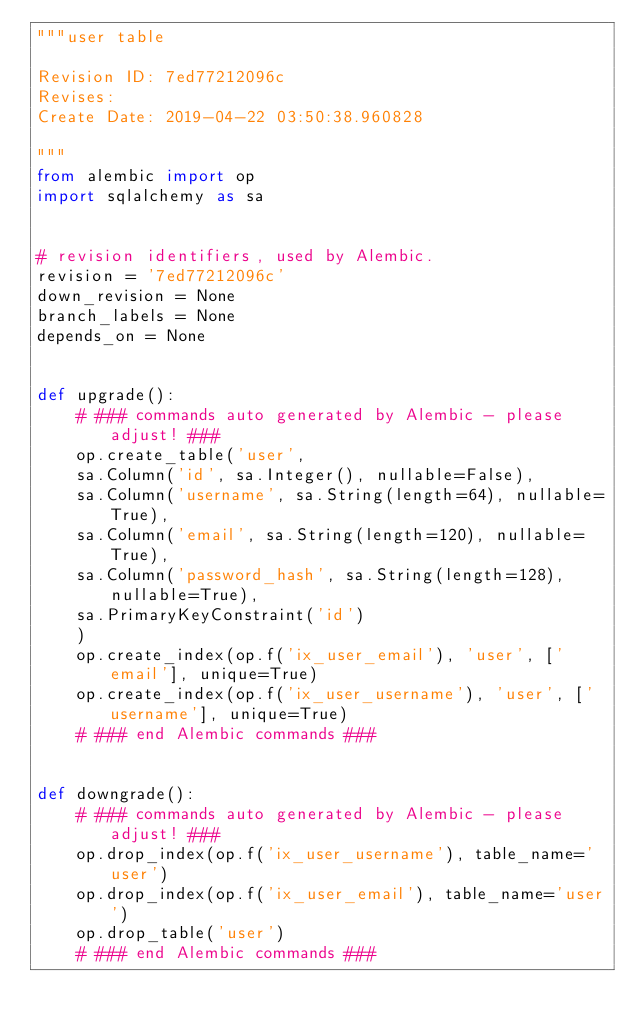<code> <loc_0><loc_0><loc_500><loc_500><_Python_>"""user table

Revision ID: 7ed77212096c
Revises: 
Create Date: 2019-04-22 03:50:38.960828

"""
from alembic import op
import sqlalchemy as sa


# revision identifiers, used by Alembic.
revision = '7ed77212096c'
down_revision = None
branch_labels = None
depends_on = None


def upgrade():
    # ### commands auto generated by Alembic - please adjust! ###
    op.create_table('user',
    sa.Column('id', sa.Integer(), nullable=False),
    sa.Column('username', sa.String(length=64), nullable=True),
    sa.Column('email', sa.String(length=120), nullable=True),
    sa.Column('password_hash', sa.String(length=128), nullable=True),
    sa.PrimaryKeyConstraint('id')
    )
    op.create_index(op.f('ix_user_email'), 'user', ['email'], unique=True)
    op.create_index(op.f('ix_user_username'), 'user', ['username'], unique=True)
    # ### end Alembic commands ###


def downgrade():
    # ### commands auto generated by Alembic - please adjust! ###
    op.drop_index(op.f('ix_user_username'), table_name='user')
    op.drop_index(op.f('ix_user_email'), table_name='user')
    op.drop_table('user')
    # ### end Alembic commands ###
</code> 